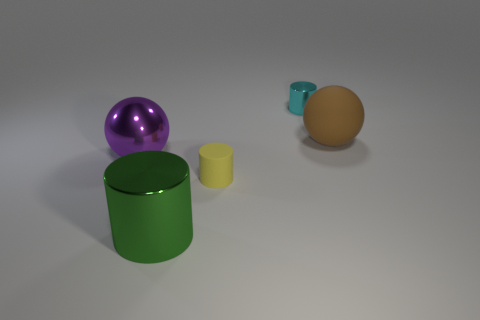Is the size of the green metallic cylinder the same as the purple ball?
Your answer should be very brief. Yes. What number of things are rubber objects behind the shiny sphere or things that are to the left of the brown object?
Your answer should be compact. 5. What number of metallic cylinders are behind the shiny cylinder that is in front of the metallic object that is on the left side of the large green thing?
Offer a terse response. 1. There is a yellow object in front of the brown rubber object; what size is it?
Make the answer very short. Small. How many purple things are the same size as the yellow cylinder?
Your response must be concise. 0. There is a cyan object; is its size the same as the matte thing that is on the left side of the cyan cylinder?
Your response must be concise. Yes. What number of objects are tiny shiny cylinders or matte objects?
Your answer should be compact. 3. What shape is the thing that is the same size as the cyan metal cylinder?
Your answer should be compact. Cylinder. Are there any other tiny purple metal things that have the same shape as the purple metal object?
Make the answer very short. No. How many small yellow objects have the same material as the brown ball?
Keep it short and to the point. 1. 